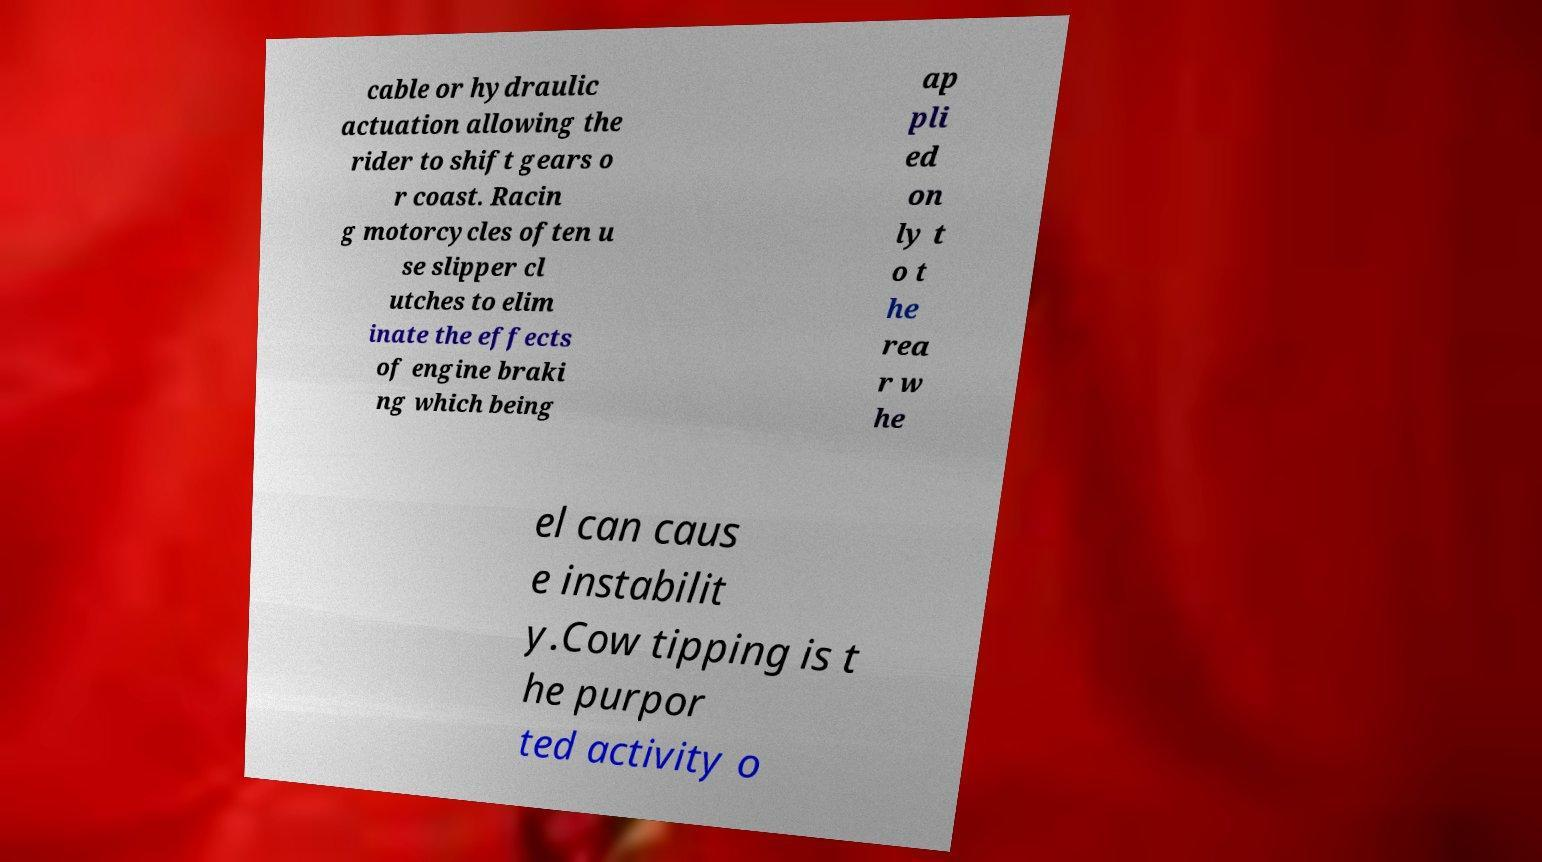I need the written content from this picture converted into text. Can you do that? cable or hydraulic actuation allowing the rider to shift gears o r coast. Racin g motorcycles often u se slipper cl utches to elim inate the effects of engine braki ng which being ap pli ed on ly t o t he rea r w he el can caus e instabilit y.Cow tipping is t he purpor ted activity o 